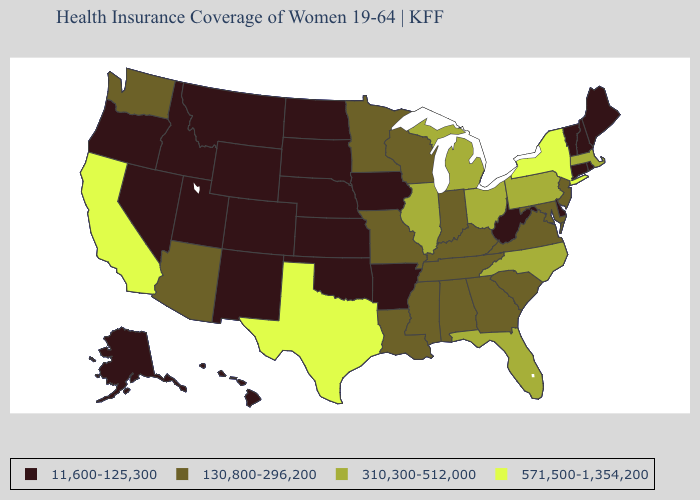What is the value of Indiana?
Concise answer only. 130,800-296,200. What is the highest value in states that border Washington?
Quick response, please. 11,600-125,300. What is the lowest value in the MidWest?
Answer briefly. 11,600-125,300. What is the lowest value in the USA?
Be succinct. 11,600-125,300. Name the states that have a value in the range 310,300-512,000?
Keep it brief. Florida, Illinois, Massachusetts, Michigan, North Carolina, Ohio, Pennsylvania. Does Virginia have a higher value than Connecticut?
Concise answer only. Yes. Does South Carolina have the lowest value in the USA?
Concise answer only. No. What is the highest value in the South ?
Concise answer only. 571,500-1,354,200. What is the value of Rhode Island?
Write a very short answer. 11,600-125,300. Does Connecticut have the same value as Colorado?
Answer briefly. Yes. Name the states that have a value in the range 310,300-512,000?
Write a very short answer. Florida, Illinois, Massachusetts, Michigan, North Carolina, Ohio, Pennsylvania. Which states hav the highest value in the South?
Quick response, please. Texas. What is the highest value in the USA?
Short answer required. 571,500-1,354,200. Name the states that have a value in the range 130,800-296,200?
Answer briefly. Alabama, Arizona, Georgia, Indiana, Kentucky, Louisiana, Maryland, Minnesota, Mississippi, Missouri, New Jersey, South Carolina, Tennessee, Virginia, Washington, Wisconsin. What is the value of Delaware?
Keep it brief. 11,600-125,300. 